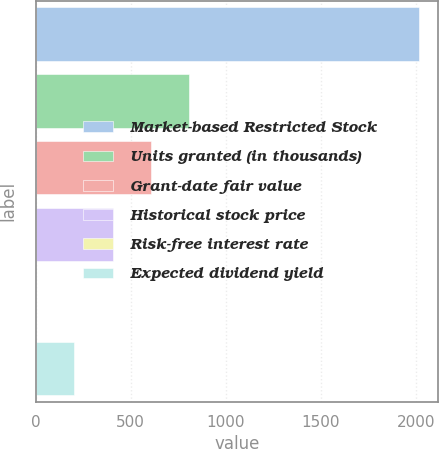Convert chart to OTSL. <chart><loc_0><loc_0><loc_500><loc_500><bar_chart><fcel>Market-based Restricted Stock<fcel>Units granted (in thousands)<fcel>Grant-date fair value<fcel>Historical stock price<fcel>Risk-free interest rate<fcel>Expected dividend yield<nl><fcel>2015<fcel>806.66<fcel>605.27<fcel>403.88<fcel>1.1<fcel>202.49<nl></chart> 